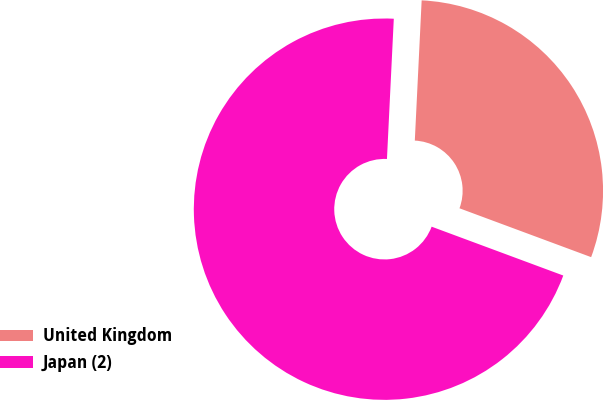<chart> <loc_0><loc_0><loc_500><loc_500><pie_chart><fcel>United Kingdom<fcel>Japan (2)<nl><fcel>29.88%<fcel>70.12%<nl></chart> 